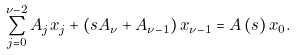Convert formula to latex. <formula><loc_0><loc_0><loc_500><loc_500>\sum _ { j = 0 } ^ { \nu - 2 } A _ { j } x _ { j } + \left ( s A _ { \nu } + A _ { \nu - 1 } \right ) x _ { \nu - 1 } = A \left ( s \right ) x _ { 0 } .</formula> 